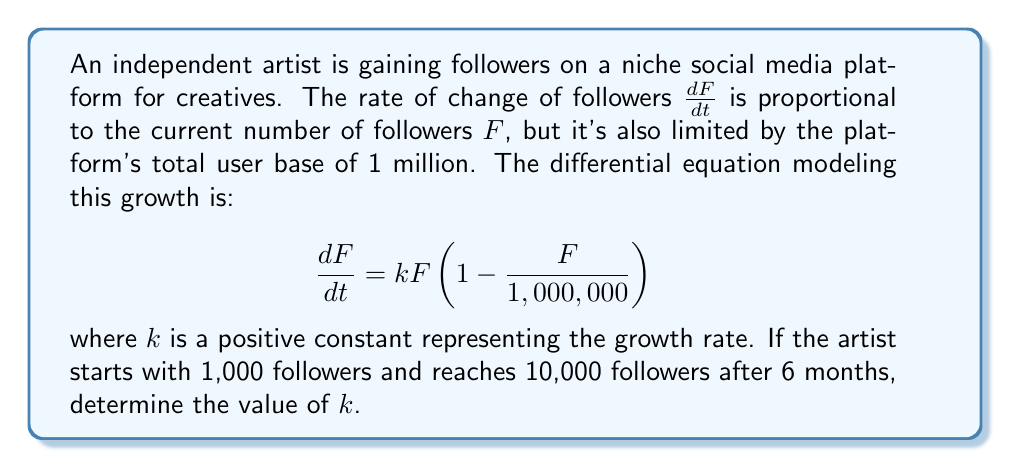Could you help me with this problem? To solve this problem, we'll follow these steps:

1) The given differential equation is a logistic growth model:
   $$\frac{dF}{dt} = kF(1 - \frac{F}{1,000,000})$$

2) The solution to this equation is:
   $$F(t) = \frac{1,000,000}{1 + Ce^{-kt}}$$
   where $C$ is a constant determined by the initial conditions.

3) We know that $F(0) = 1,000$, so:
   $$1,000 = \frac{1,000,000}{1 + C}$$
   Solving for $C$:
   $$C = 999$$

4) After 6 months (t = 0.5 years), $F(0.5) = 10,000$:
   $$10,000 = \frac{1,000,000}{1 + 999e^{-0.5k}}$$

5) Solve this equation for $k$:
   $$1 + 999e^{-0.5k} = 100$$
   $$999e^{-0.5k} = 99$$
   $$e^{-0.5k} = \frac{1}{10}$$
   $$-0.5k = \ln(\frac{1}{10}) = -2.3026$$
   $$k = 4.6052$$

Therefore, the growth rate $k$ is approximately 4.6052 per year.
Answer: $k \approx 4.6052$ per year 